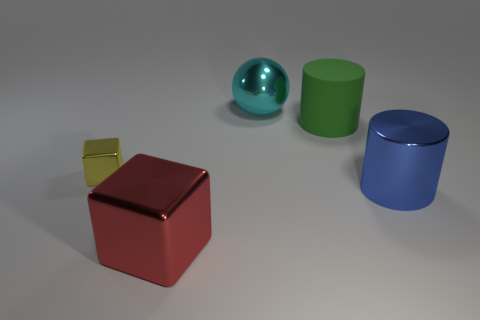Add 5 tiny metallic objects. How many objects exist? 10 Subtract all blocks. How many objects are left? 3 Subtract all tiny brown metallic cylinders. Subtract all green cylinders. How many objects are left? 4 Add 2 large red shiny things. How many large red shiny things are left? 3 Add 1 blue objects. How many blue objects exist? 2 Subtract 0 cyan blocks. How many objects are left? 5 